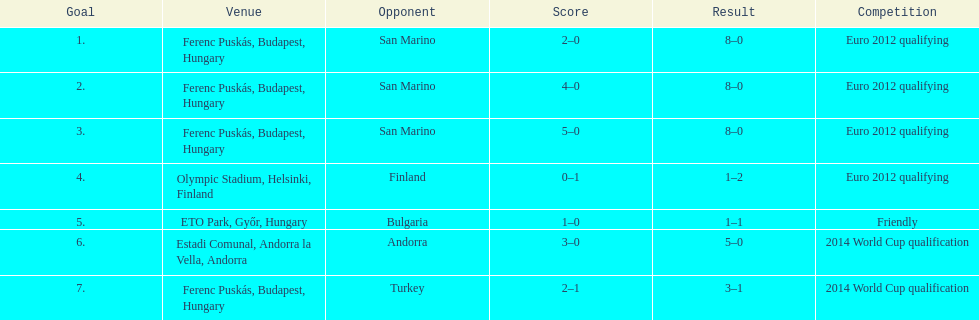How many goals were scored at the euro 2012 qualifying competition? 12. 